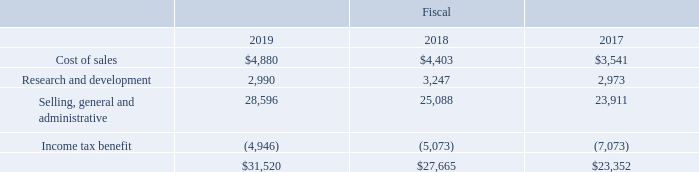Stock Compensation Expense
The following table shows total stock-based compensation expense and related tax benefits included in the Consolidated Statements of Operations for fiscal 2019, 2018 and 2017 (in thousands):
As a result of our acquisition of Rofin on November 7, 2016, we made a payment of $15.3 million due to the cancellation of options held by employees of Rofin. The payment was allocated between total estimated merger consideration of $11.1 million and post-merger stock-based compensation expense of $4.2 million, recorded in the first quarter of fiscal 2017, based on the portion of the total service period of the underlying options that have not been completed by the merger date.
During fiscal 2019, $4.8 million of stock-based compensation cost was capitalized as part of inventory for all stock plans, $4.8 million was amortized into cost of sales and $1.5 million remained in inventory at September 28, 2019. During fiscal 2018, $4.7 million of stock-based compensation cost was capitalized as part of inventory for all stock plans, $4.4 million was amortized into cost of sales and $1.5 million remained in inventory at September 29, 2018.
At fiscal 2019 year-end, the total compensation cost related to unvested stock-based awards granted to employees under our stock plans but not yet recognized was approximately $33.1 million. We do not estimate forfeitures. This cost will be amortized on a straight-line basis over a weighted-average period of approximately 1.5 years.
What was the amount of Research and development in 2019?
Answer scale should be: thousand. 2,990. What was the amount of income tax benefit in 2018?
Answer scale should be: thousand. (5,073). In which years was cost of sales calculated? 2019, 2018, 2017. In which year was the amount of Research and development largest? 3,247>2,990>2,973
Answer: 2018. What was the change in  Research and development in 2019 from 2018?
Answer scale should be: thousand. 2,990-3,247
Answer: -257. What was the percentage change in Research and development in 2019 from 2018?
Answer scale should be: percent. (2,990-3,247)/3,247
Answer: -7.91. 